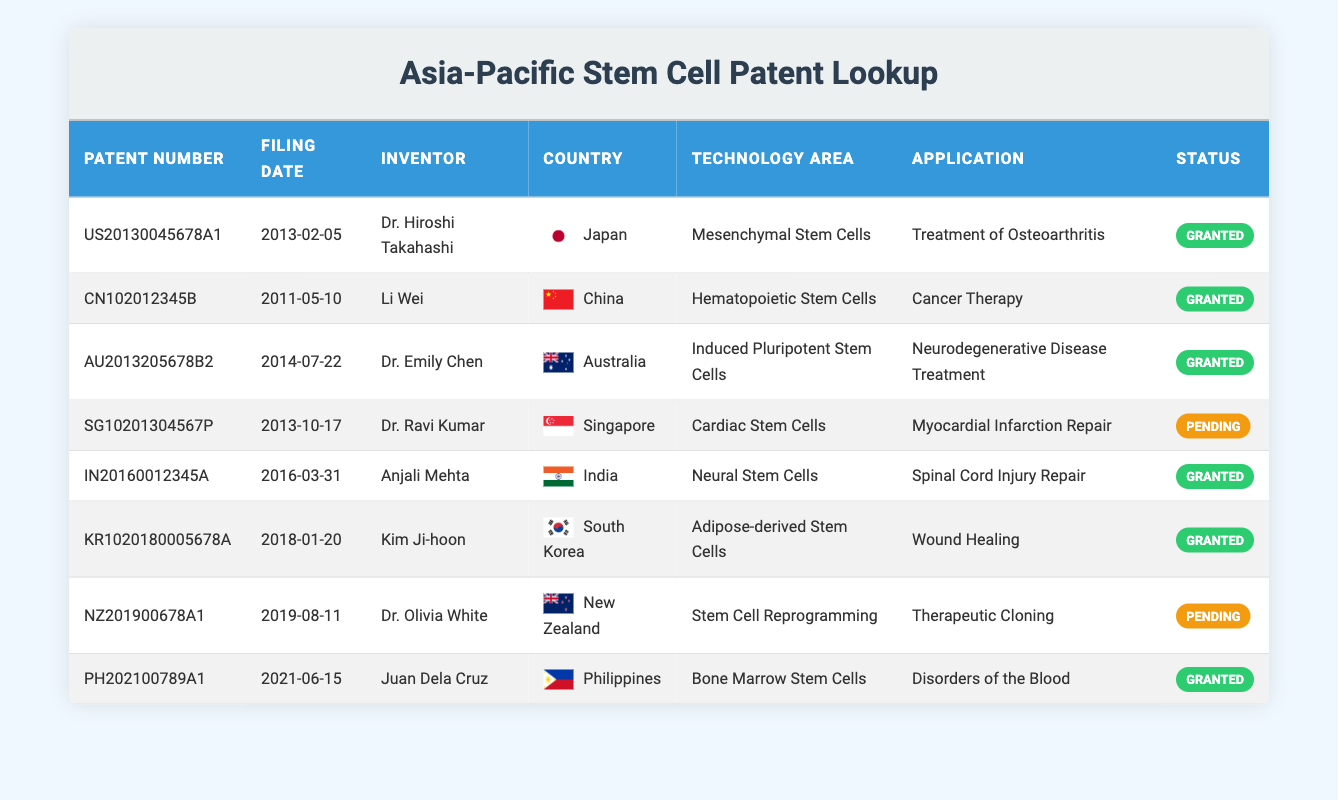What is the patent number for the application related to "Therapeutic Cloning"? In the table, the application "Therapeutic Cloning" is listed under the patent number NZ201900678A1.
Answer: NZ201900678A1 Which country has the highest number of granted patents in this table? The United States, China, Australia, India, South Korea, and the Philippines each have at least one granted patent. From the data, since we have four granted patents (Japan, China, Australia, India, South Korea, and Philippines), we do not see any repetitions, so they all have one each. Therefore, no single country has a higher count than others.
Answer: All have one each Who is the inventor associated with the "Wound Healing" application? The application "Wound Healing" is associated with the inventor Kim Ji-hoon, as shown in the table.
Answer: Kim Ji-hoon How many patents are currently pending status? Referring to the table, there are two patents listed with a pending status: SG10201304567P and NZ201900678A1, which sums up to a total of two pending patents.
Answer: 2 Is there a patent for "Myocardial Infarction Repair" from Singapore? The table indicates that the patent SG10201304567P is indeed for "Myocardial Infarction Repair," and it is listed under Singapore.
Answer: Yes What is the average filing year of patents related to stem-cell therapy in this table? The filing years are 2013, 2011, 2014, 2013, 2016, 2018, 2019, and 2021. Calculating the average: (2013 + 2011 + 2014 + 2013 + 2016 + 2018 + 2019 + 2021) / 8 = 2016.25, rounding down gives us 2016.
Answer: 2016 Which patent application is for "Spinal Cord Injury Repair"? The patent application for "Spinal Cord Injury Repair" is described in the patent number IN20160012345A, associated with the inventor Anjali Mehta.
Answer: IN20160012345A How many countries are represented in the table? The table lists patents from Japan, China, Australia, Singapore, India, South Korea, New Zealand, and the Philippines, totaling eight distinct countries.
Answer: 8 What is the status of the patent filed by Dr. Ravi Kumar from Singapore? The patent filed by Dr. Ravi Kumar, SG10201304567P, is currently listed as pending in the table.
Answer: Pending 